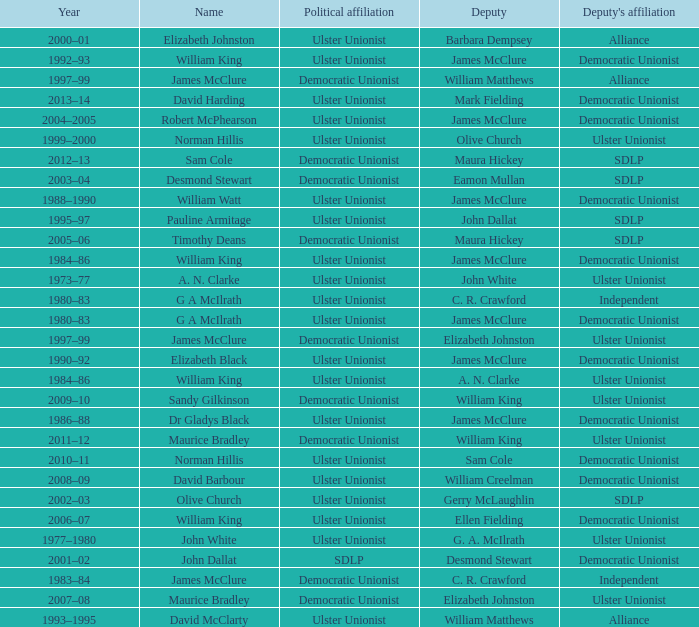What is the name of the Deputy when the Name was elizabeth black? James McClure. 